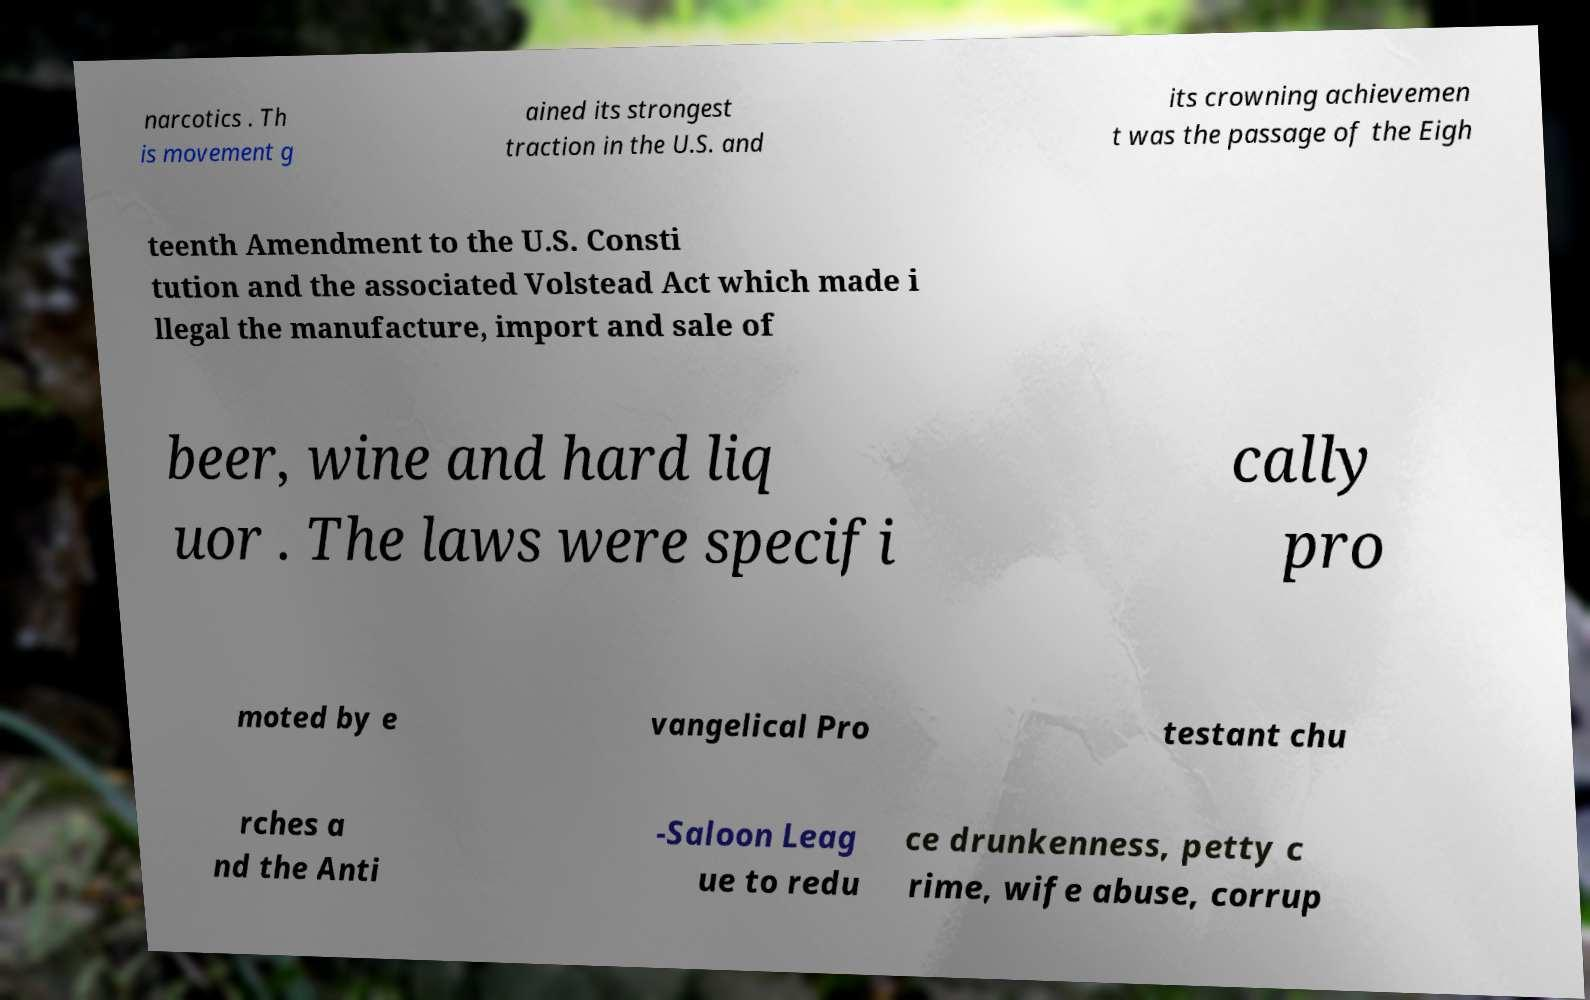Please read and relay the text visible in this image. What does it say? narcotics . Th is movement g ained its strongest traction in the U.S. and its crowning achievemen t was the passage of the Eigh teenth Amendment to the U.S. Consti tution and the associated Volstead Act which made i llegal the manufacture, import and sale of beer, wine and hard liq uor . The laws were specifi cally pro moted by e vangelical Pro testant chu rches a nd the Anti -Saloon Leag ue to redu ce drunkenness, petty c rime, wife abuse, corrup 